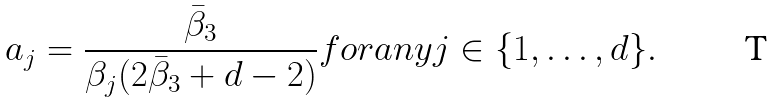<formula> <loc_0><loc_0><loc_500><loc_500>a _ { j } = \frac { \bar { \beta } _ { 3 } } { \beta _ { j } ( 2 \bar { \beta } _ { 3 } + d - 2 ) } f o r a n y j \in \{ 1 , \dots , d \} .</formula> 